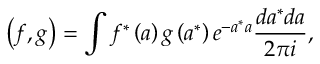Convert formula to latex. <formula><loc_0><loc_0><loc_500><loc_500>\left ( f , g \right ) = \int f ^ { \ast } \left ( a \right ) g \left ( a ^ { \ast } \right ) e ^ { - a ^ { \ast } a } \frac { d a ^ { \ast } d a } { 2 \pi i } ,</formula> 